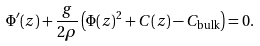<formula> <loc_0><loc_0><loc_500><loc_500>\Phi ^ { \prime } ( z ) + \frac { g } { 2 \rho } \left ( \Phi ( z ) ^ { 2 } + C ( z ) - C _ { \text {bulk} } \right ) = 0 .</formula> 